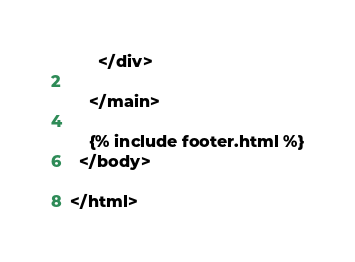<code> <loc_0><loc_0><loc_500><loc_500><_HTML_>      </div>

    </main>

    {% include footer.html %}
  </body>

</html>
</code> 